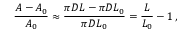Convert formula to latex. <formula><loc_0><loc_0><loc_500><loc_500>\frac { A - A _ { 0 } } { A _ { 0 } } \approx \frac { \pi D L - \pi D L _ { 0 } } { \pi D L _ { 0 } } = \frac { L } { L _ { 0 } } - 1 \, ,</formula> 